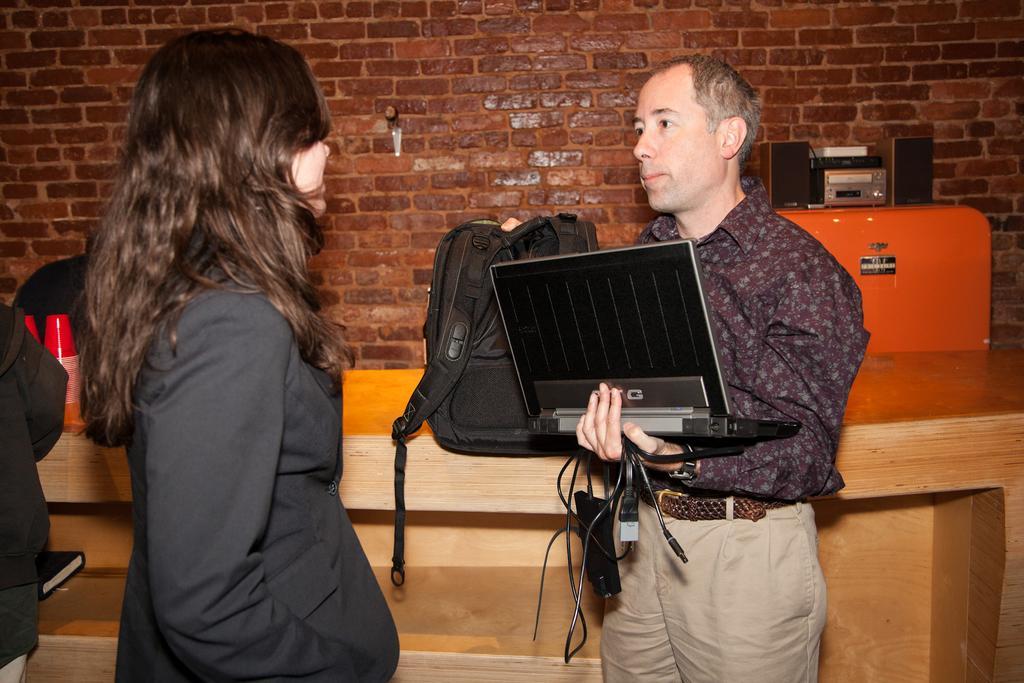How would you summarize this image in a sentence or two? In this picture we can observe a woman wearing black color coat. There is a man wearing brown color shirt and holding a laptop in his hand. There is a bag in the other hand of a man. We can observe a cream color desk. In the background there is a brown color wall. 